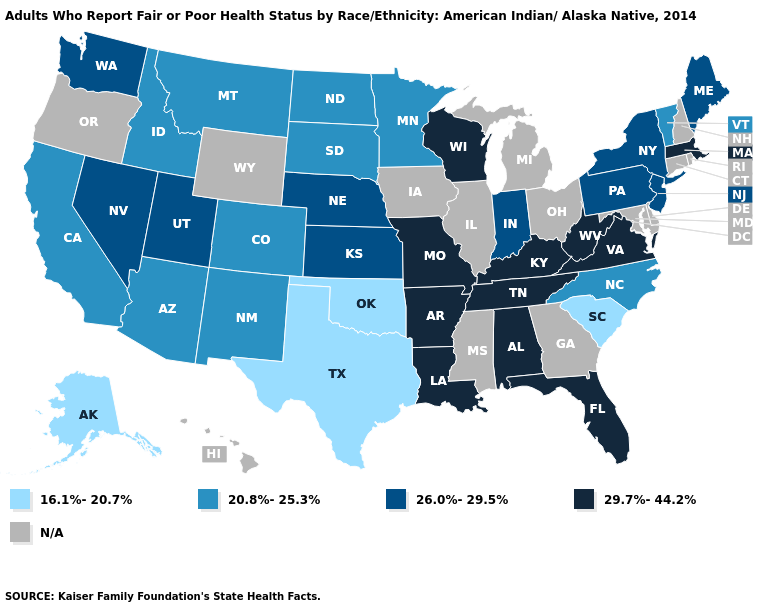What is the highest value in states that border Florida?
Quick response, please. 29.7%-44.2%. What is the value of Rhode Island?
Answer briefly. N/A. Name the states that have a value in the range 26.0%-29.5%?
Keep it brief. Indiana, Kansas, Maine, Nebraska, Nevada, New Jersey, New York, Pennsylvania, Utah, Washington. What is the value of Michigan?
Concise answer only. N/A. What is the value of Iowa?
Answer briefly. N/A. How many symbols are there in the legend?
Short answer required. 5. Is the legend a continuous bar?
Concise answer only. No. What is the lowest value in states that border Texas?
Concise answer only. 16.1%-20.7%. Name the states that have a value in the range 26.0%-29.5%?
Concise answer only. Indiana, Kansas, Maine, Nebraska, Nevada, New Jersey, New York, Pennsylvania, Utah, Washington. What is the value of Florida?
Give a very brief answer. 29.7%-44.2%. Name the states that have a value in the range 29.7%-44.2%?
Write a very short answer. Alabama, Arkansas, Florida, Kentucky, Louisiana, Massachusetts, Missouri, Tennessee, Virginia, West Virginia, Wisconsin. Does Massachusetts have the highest value in the Northeast?
Concise answer only. Yes. What is the value of Wisconsin?
Short answer required. 29.7%-44.2%. What is the value of Minnesota?
Write a very short answer. 20.8%-25.3%. 